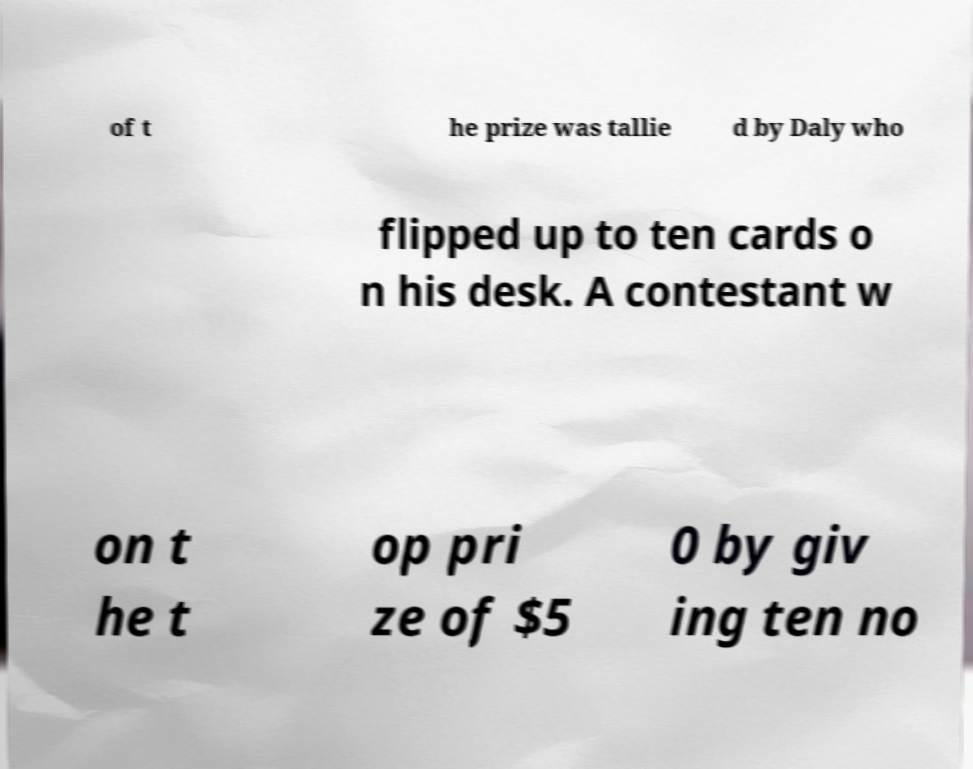For documentation purposes, I need the text within this image transcribed. Could you provide that? of t he prize was tallie d by Daly who flipped up to ten cards o n his desk. A contestant w on t he t op pri ze of $5 0 by giv ing ten no 